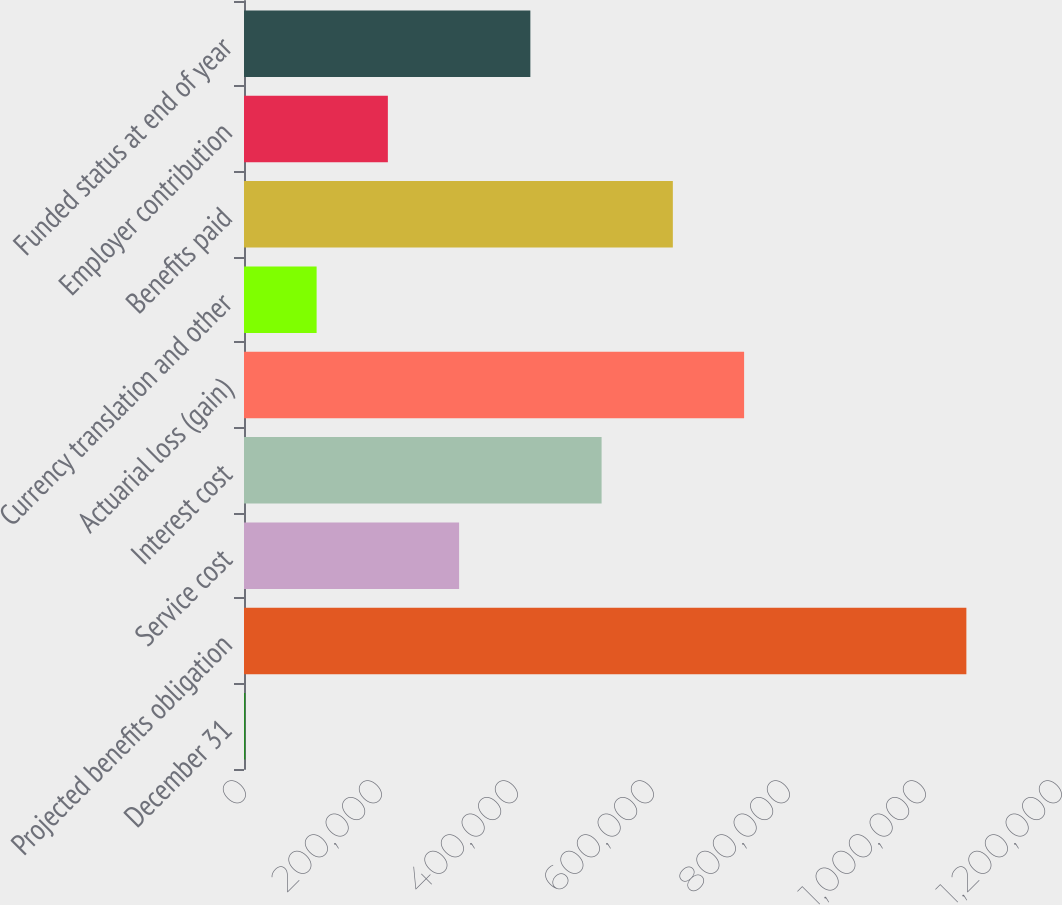Convert chart. <chart><loc_0><loc_0><loc_500><loc_500><bar_chart><fcel>December 31<fcel>Projected benefits obligation<fcel>Service cost<fcel>Interest cost<fcel>Actuarial loss (gain)<fcel>Currency translation and other<fcel>Benefits paid<fcel>Employer contribution<fcel>Funded status at end of year<nl><fcel>2010<fcel>1.06231e+06<fcel>316337<fcel>525888<fcel>735439<fcel>106786<fcel>630664<fcel>211561<fcel>421112<nl></chart> 